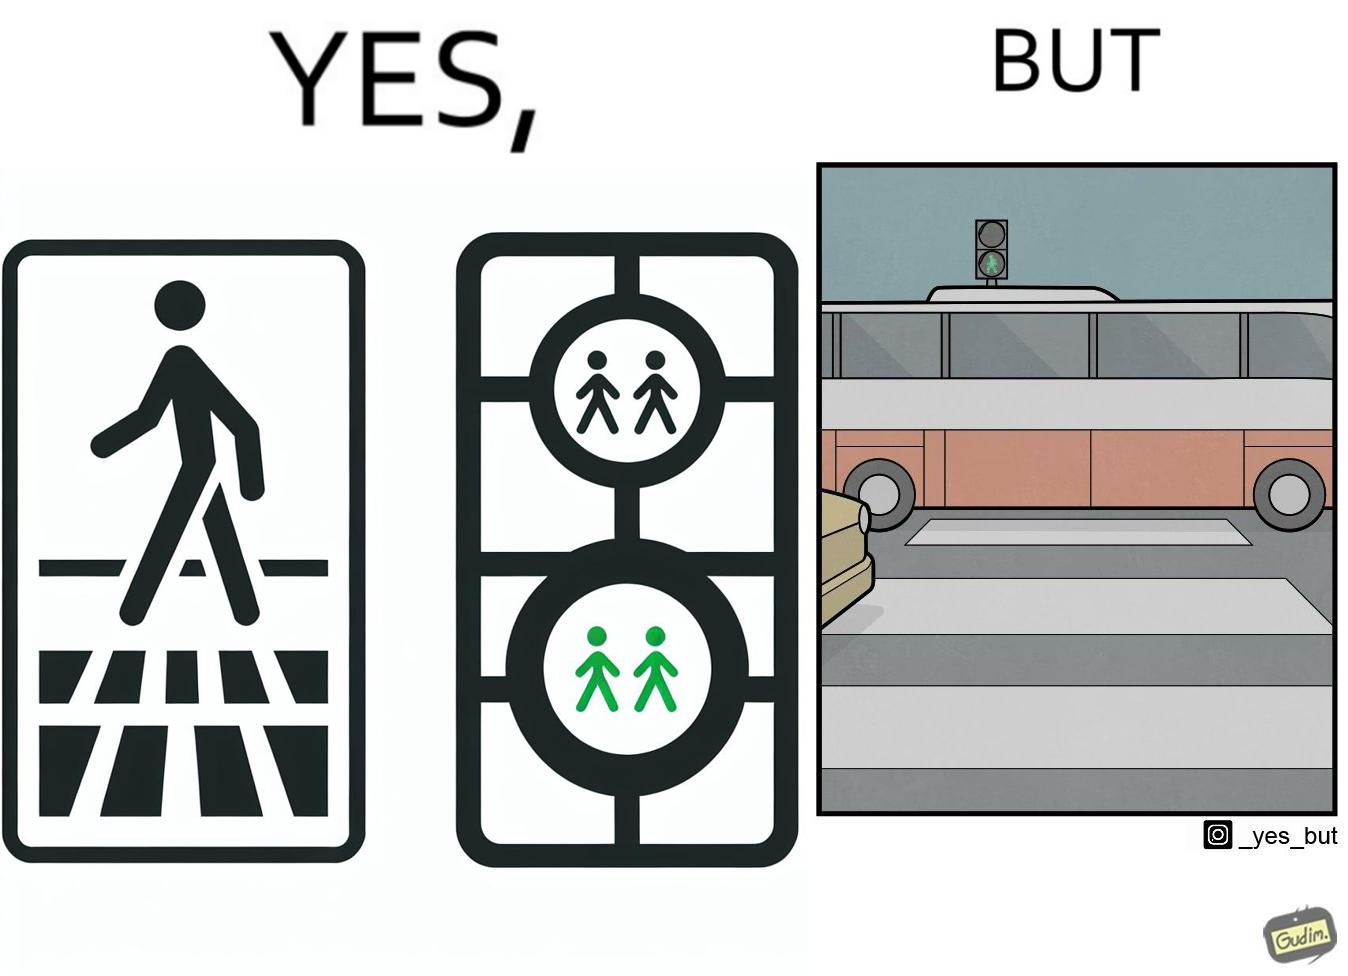What do you see in each half of this image? In the left part of the image: a traffic signal for the pedestrians and the signal is green, so pedestrians can cross the road In the right part of the image: a bus standing on the zebra crossing, while the traffic signal is green for the pedestrians symbolising  they can cross the road now 